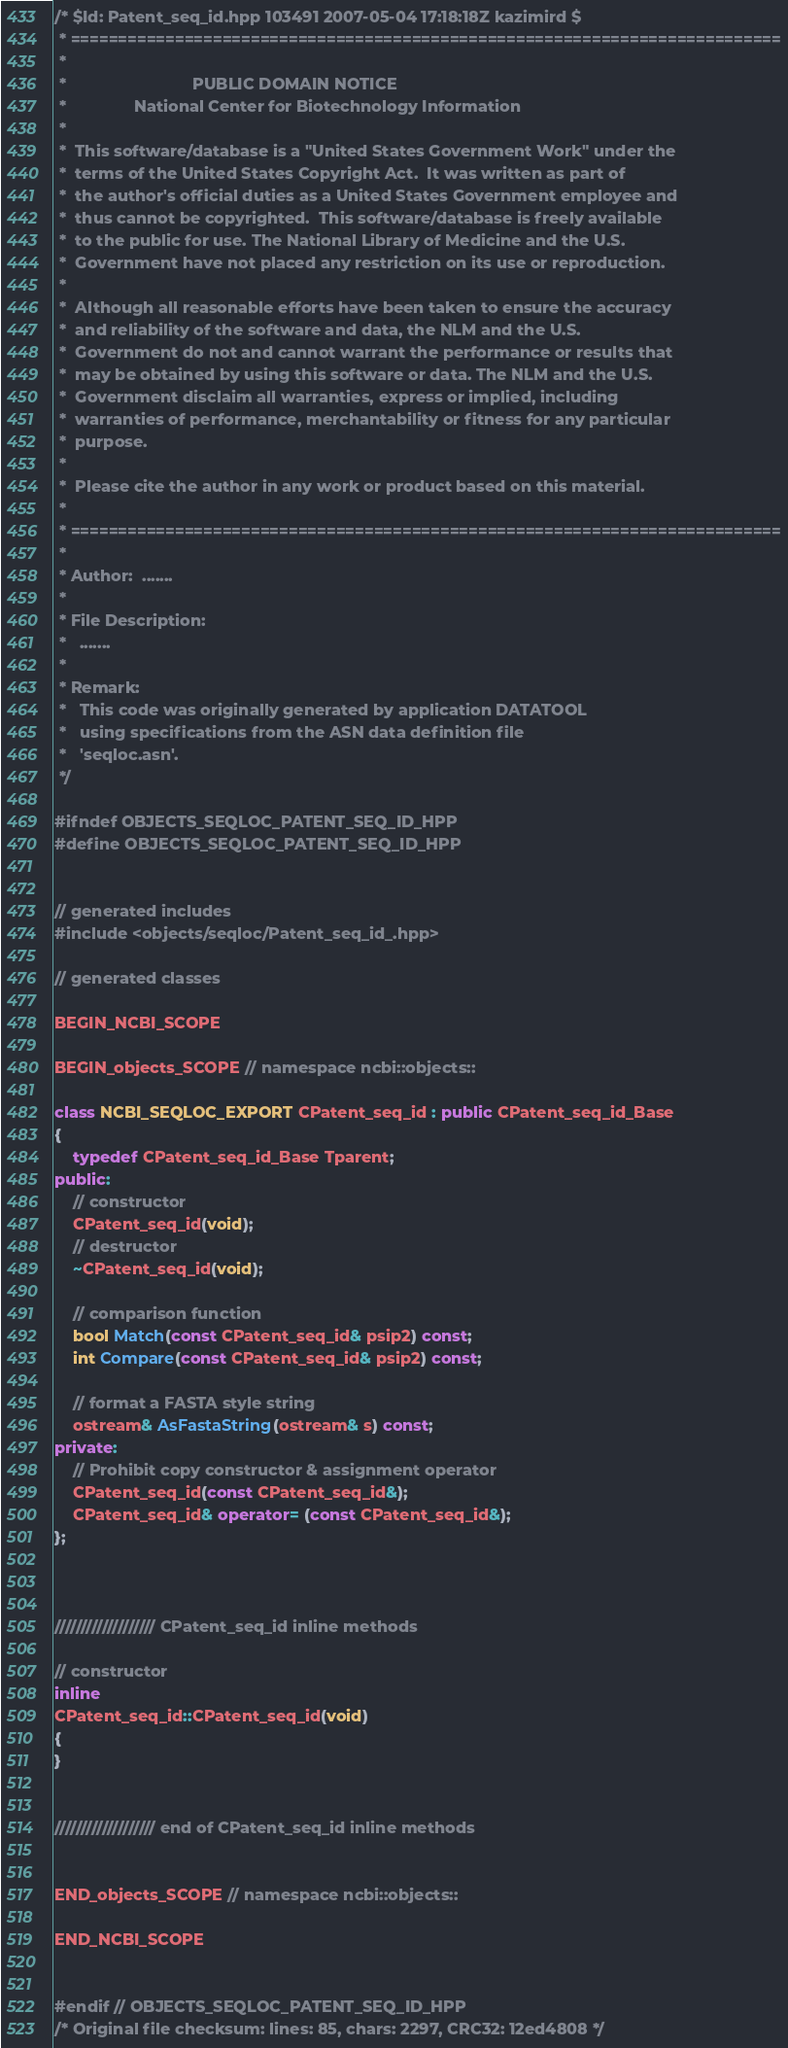Convert code to text. <code><loc_0><loc_0><loc_500><loc_500><_C++_>/* $Id: Patent_seq_id.hpp 103491 2007-05-04 17:18:18Z kazimird $
 * ===========================================================================
 *
 *                            PUBLIC DOMAIN NOTICE
 *               National Center for Biotechnology Information
 *
 *  This software/database is a "United States Government Work" under the
 *  terms of the United States Copyright Act.  It was written as part of
 *  the author's official duties as a United States Government employee and
 *  thus cannot be copyrighted.  This software/database is freely available
 *  to the public for use. The National Library of Medicine and the U.S.
 *  Government have not placed any restriction on its use or reproduction.
 *
 *  Although all reasonable efforts have been taken to ensure the accuracy
 *  and reliability of the software and data, the NLM and the U.S.
 *  Government do not and cannot warrant the performance or results that
 *  may be obtained by using this software or data. The NLM and the U.S.
 *  Government disclaim all warranties, express or implied, including
 *  warranties of performance, merchantability or fitness for any particular
 *  purpose.
 *
 *  Please cite the author in any work or product based on this material.
 *
 * ===========================================================================
 *
 * Author:  .......
 *
 * File Description:
 *   .......
 *
 * Remark:
 *   This code was originally generated by application DATATOOL
 *   using specifications from the ASN data definition file
 *   'seqloc.asn'.
 */

#ifndef OBJECTS_SEQLOC_PATENT_SEQ_ID_HPP
#define OBJECTS_SEQLOC_PATENT_SEQ_ID_HPP


// generated includes
#include <objects/seqloc/Patent_seq_id_.hpp>

// generated classes

BEGIN_NCBI_SCOPE

BEGIN_objects_SCOPE // namespace ncbi::objects::

class NCBI_SEQLOC_EXPORT CPatent_seq_id : public CPatent_seq_id_Base
{
    typedef CPatent_seq_id_Base Tparent;
public:
    // constructor
    CPatent_seq_id(void);
    // destructor
    ~CPatent_seq_id(void);

    // comparison function
    bool Match(const CPatent_seq_id& psip2) const;
    int Compare(const CPatent_seq_id& psip2) const;

    // format a FASTA style string
    ostream& AsFastaString(ostream& s) const;
private:
    // Prohibit copy constructor & assignment operator
    CPatent_seq_id(const CPatent_seq_id&);
    CPatent_seq_id& operator= (const CPatent_seq_id&);
};



/////////////////// CPatent_seq_id inline methods

// constructor
inline
CPatent_seq_id::CPatent_seq_id(void)
{
}


/////////////////// end of CPatent_seq_id inline methods


END_objects_SCOPE // namespace ncbi::objects::

END_NCBI_SCOPE


#endif // OBJECTS_SEQLOC_PATENT_SEQ_ID_HPP
/* Original file checksum: lines: 85, chars: 2297, CRC32: 12ed4808 */
</code> 